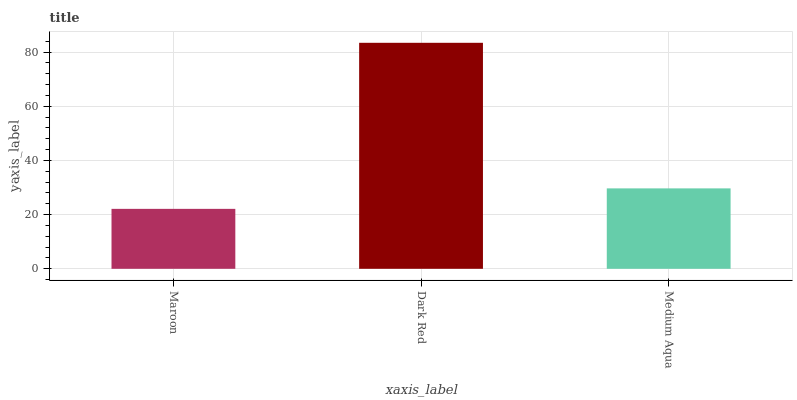Is Maroon the minimum?
Answer yes or no. Yes. Is Dark Red the maximum?
Answer yes or no. Yes. Is Medium Aqua the minimum?
Answer yes or no. No. Is Medium Aqua the maximum?
Answer yes or no. No. Is Dark Red greater than Medium Aqua?
Answer yes or no. Yes. Is Medium Aqua less than Dark Red?
Answer yes or no. Yes. Is Medium Aqua greater than Dark Red?
Answer yes or no. No. Is Dark Red less than Medium Aqua?
Answer yes or no. No. Is Medium Aqua the high median?
Answer yes or no. Yes. Is Medium Aqua the low median?
Answer yes or no. Yes. Is Dark Red the high median?
Answer yes or no. No. Is Dark Red the low median?
Answer yes or no. No. 